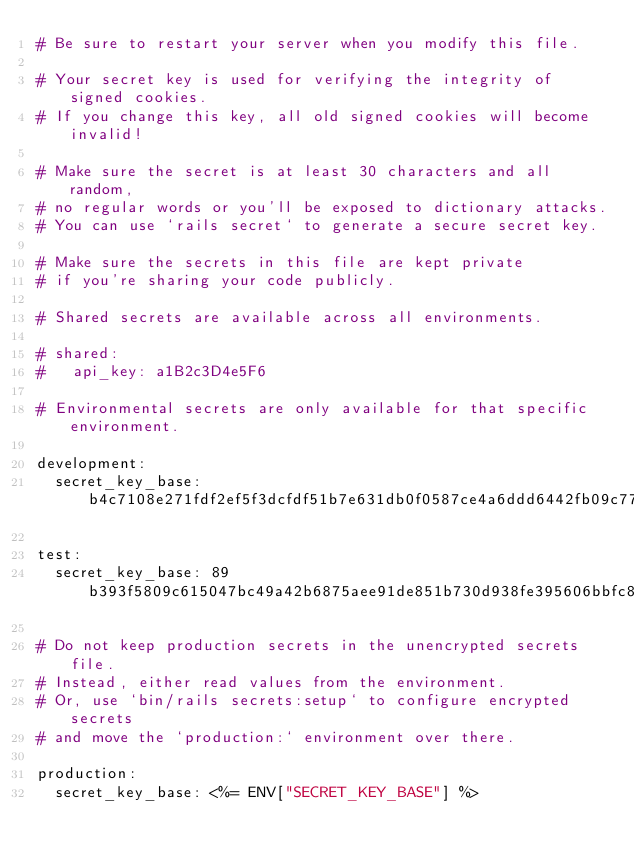Convert code to text. <code><loc_0><loc_0><loc_500><loc_500><_YAML_># Be sure to restart your server when you modify this file.

# Your secret key is used for verifying the integrity of signed cookies.
# If you change this key, all old signed cookies will become invalid!

# Make sure the secret is at least 30 characters and all random,
# no regular words or you'll be exposed to dictionary attacks.
# You can use `rails secret` to generate a secure secret key.

# Make sure the secrets in this file are kept private
# if you're sharing your code publicly.

# Shared secrets are available across all environments.

# shared:
#   api_key: a1B2c3D4e5F6

# Environmental secrets are only available for that specific environment.

development:
  secret_key_base: b4c7108e271fdf2ef5f3dcfdf51b7e631db0f0587ce4a6ddd6442fb09c77e8f5409ca7fed9fd646adea7c5d838329d1d78e75bae188eebf1a80000f27f6a8c8b

test:
  secret_key_base: 89b393f5809c615047bc49a42b6875aee91de851b730d938fe395606bbfc81a01fb8a7477cbfea33ab670e6febfa454bd3cb1ee105b0a4690fa8eac0600a956e

# Do not keep production secrets in the unencrypted secrets file.
# Instead, either read values from the environment.
# Or, use `bin/rails secrets:setup` to configure encrypted secrets
# and move the `production:` environment over there.

production:
  secret_key_base: <%= ENV["SECRET_KEY_BASE"] %>
</code> 